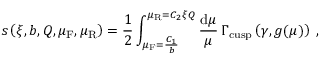Convert formula to latex. <formula><loc_0><loc_0><loc_500><loc_500>s \left ( \xi , b , Q , \mu _ { F } , \mu _ { R } \right ) = \frac { 1 } { 2 } \int _ { \mu _ { F } = \frac { C _ { 1 } } { b } } ^ { \mu _ { R } = C _ { 2 } \xi Q } \frac { d \mu } { \mu } \, \Gamma _ { c u s p } \left ( \gamma , g ( \mu ) \right ) \, ,</formula> 